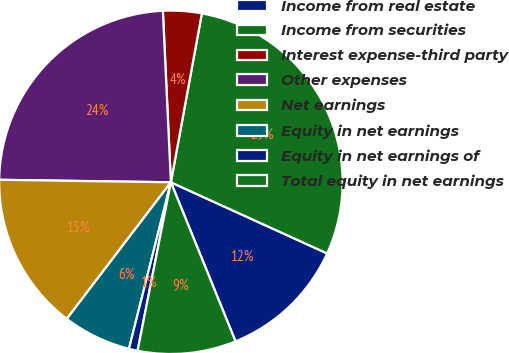Convert chart. <chart><loc_0><loc_0><loc_500><loc_500><pie_chart><fcel>Income from real estate<fcel>Income from securities<fcel>Interest expense-third party<fcel>Other expenses<fcel>Net earnings<fcel>Equity in net earnings<fcel>Equity in net earnings of<fcel>Total equity in net earnings<nl><fcel>12.06%<fcel>28.92%<fcel>3.63%<fcel>24.03%<fcel>14.87%<fcel>6.44%<fcel>0.82%<fcel>9.25%<nl></chart> 